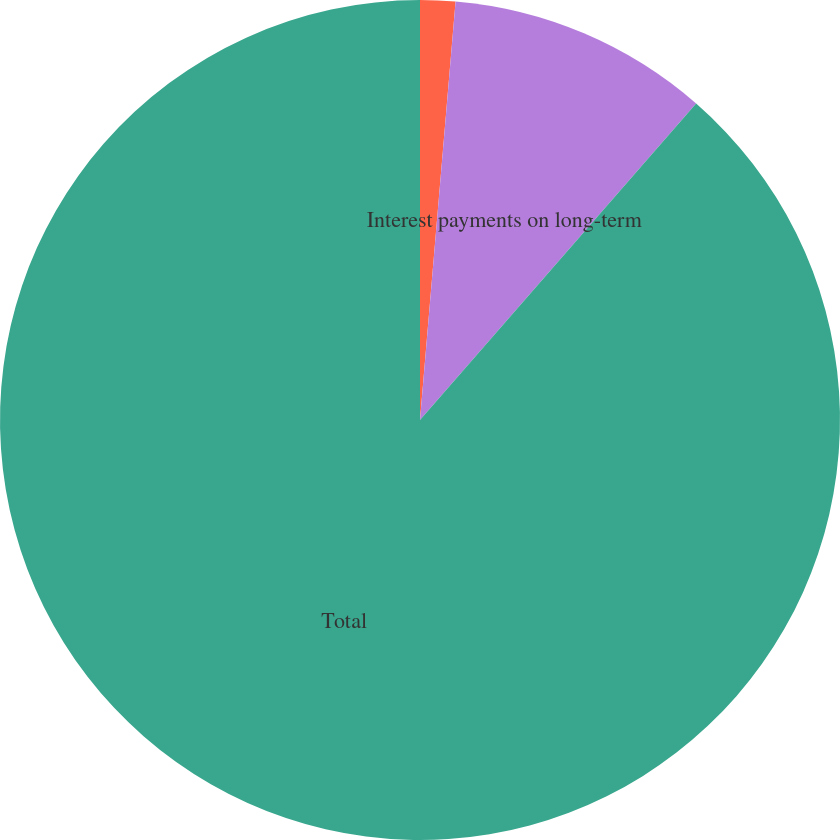Convert chart to OTSL. <chart><loc_0><loc_0><loc_500><loc_500><pie_chart><fcel>Operating leases<fcel>Interest payments on long-term<fcel>Total<nl><fcel>1.35%<fcel>10.07%<fcel>88.58%<nl></chart> 